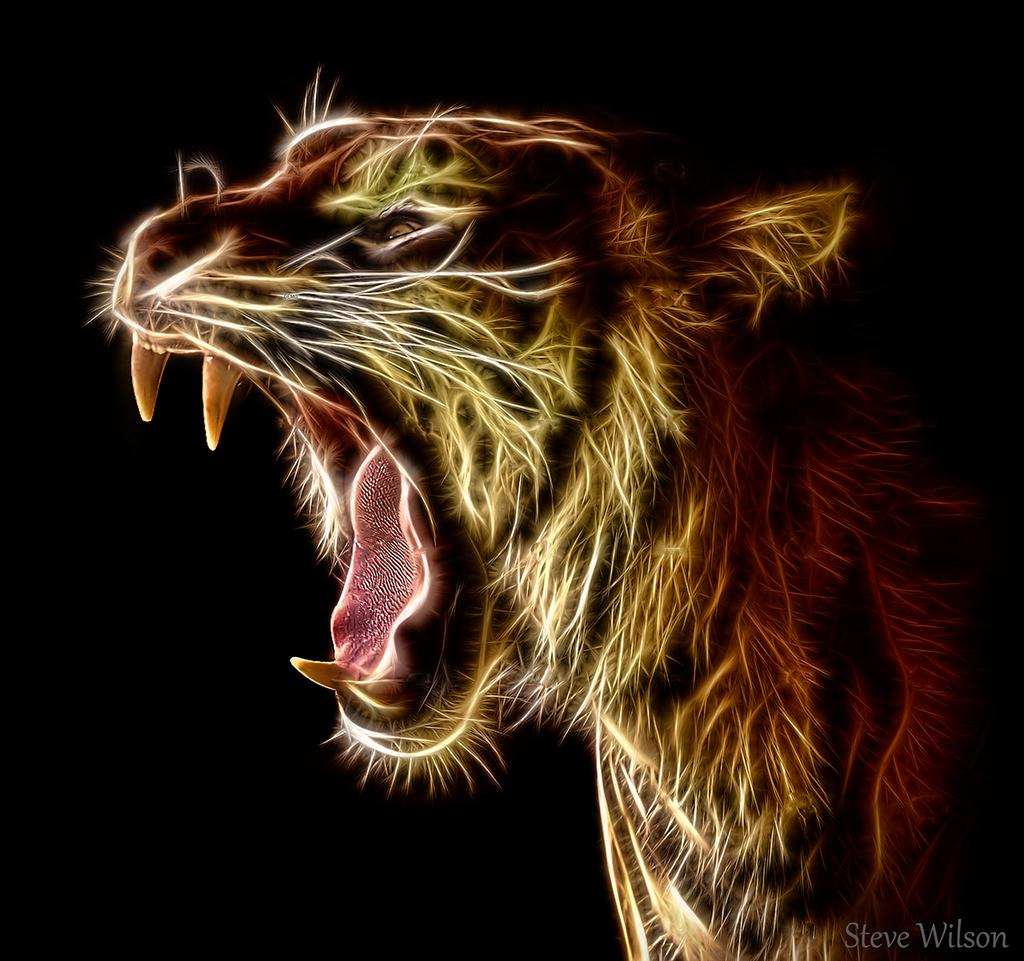What type of subject is present in the image? There is an animal in the image. Can you describe any characteristics of the image itself? The image appears to be edited. What can be observed about the background of the image? The background of the image is dark. Is there a woman carrying a basket in the image? No, there is no woman or basket present in the image. 